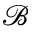<formula> <loc_0><loc_0><loc_500><loc_500>\mathcal { B }</formula> 